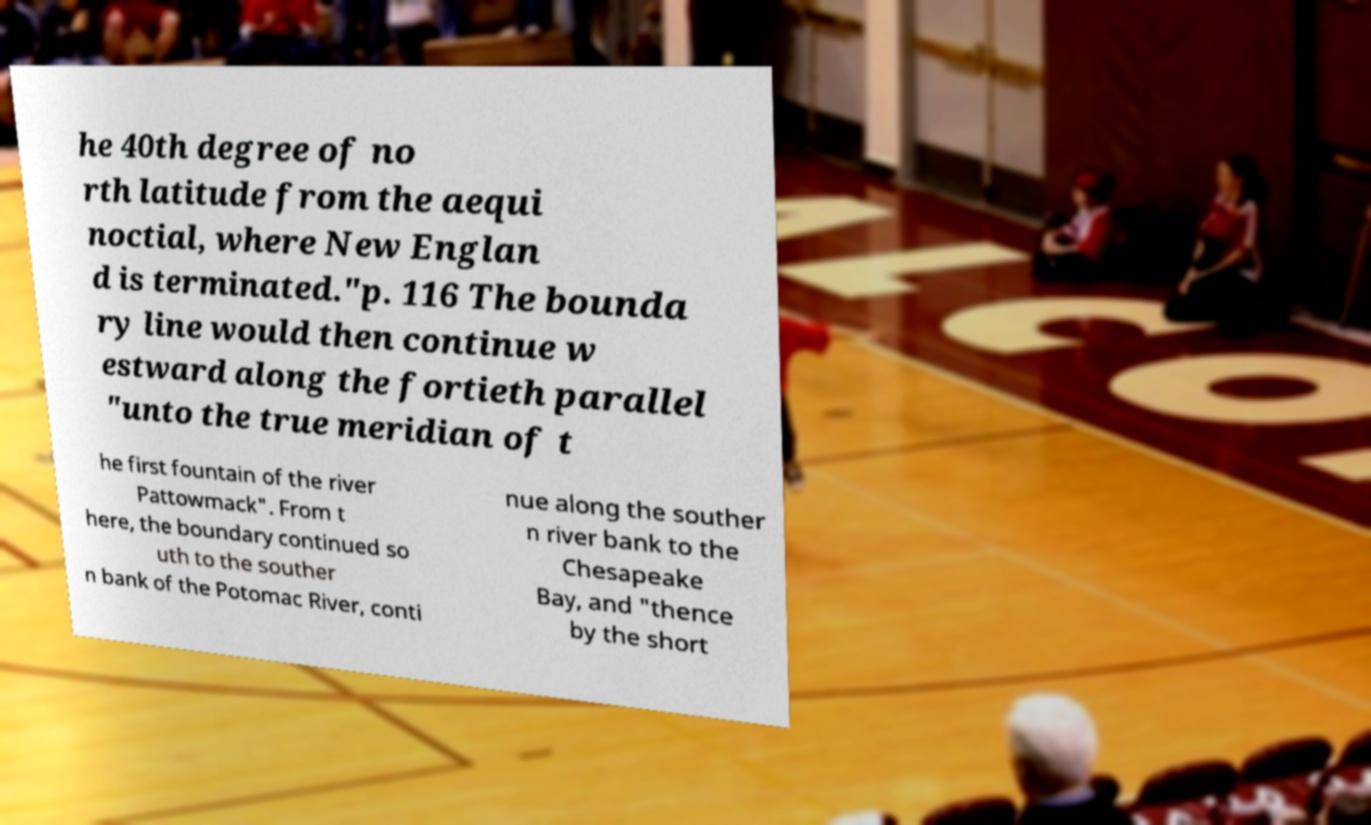What messages or text are displayed in this image? I need them in a readable, typed format. he 40th degree of no rth latitude from the aequi noctial, where New Englan d is terminated."p. 116 The bounda ry line would then continue w estward along the fortieth parallel "unto the true meridian of t he first fountain of the river Pattowmack". From t here, the boundary continued so uth to the souther n bank of the Potomac River, conti nue along the souther n river bank to the Chesapeake Bay, and "thence by the short 